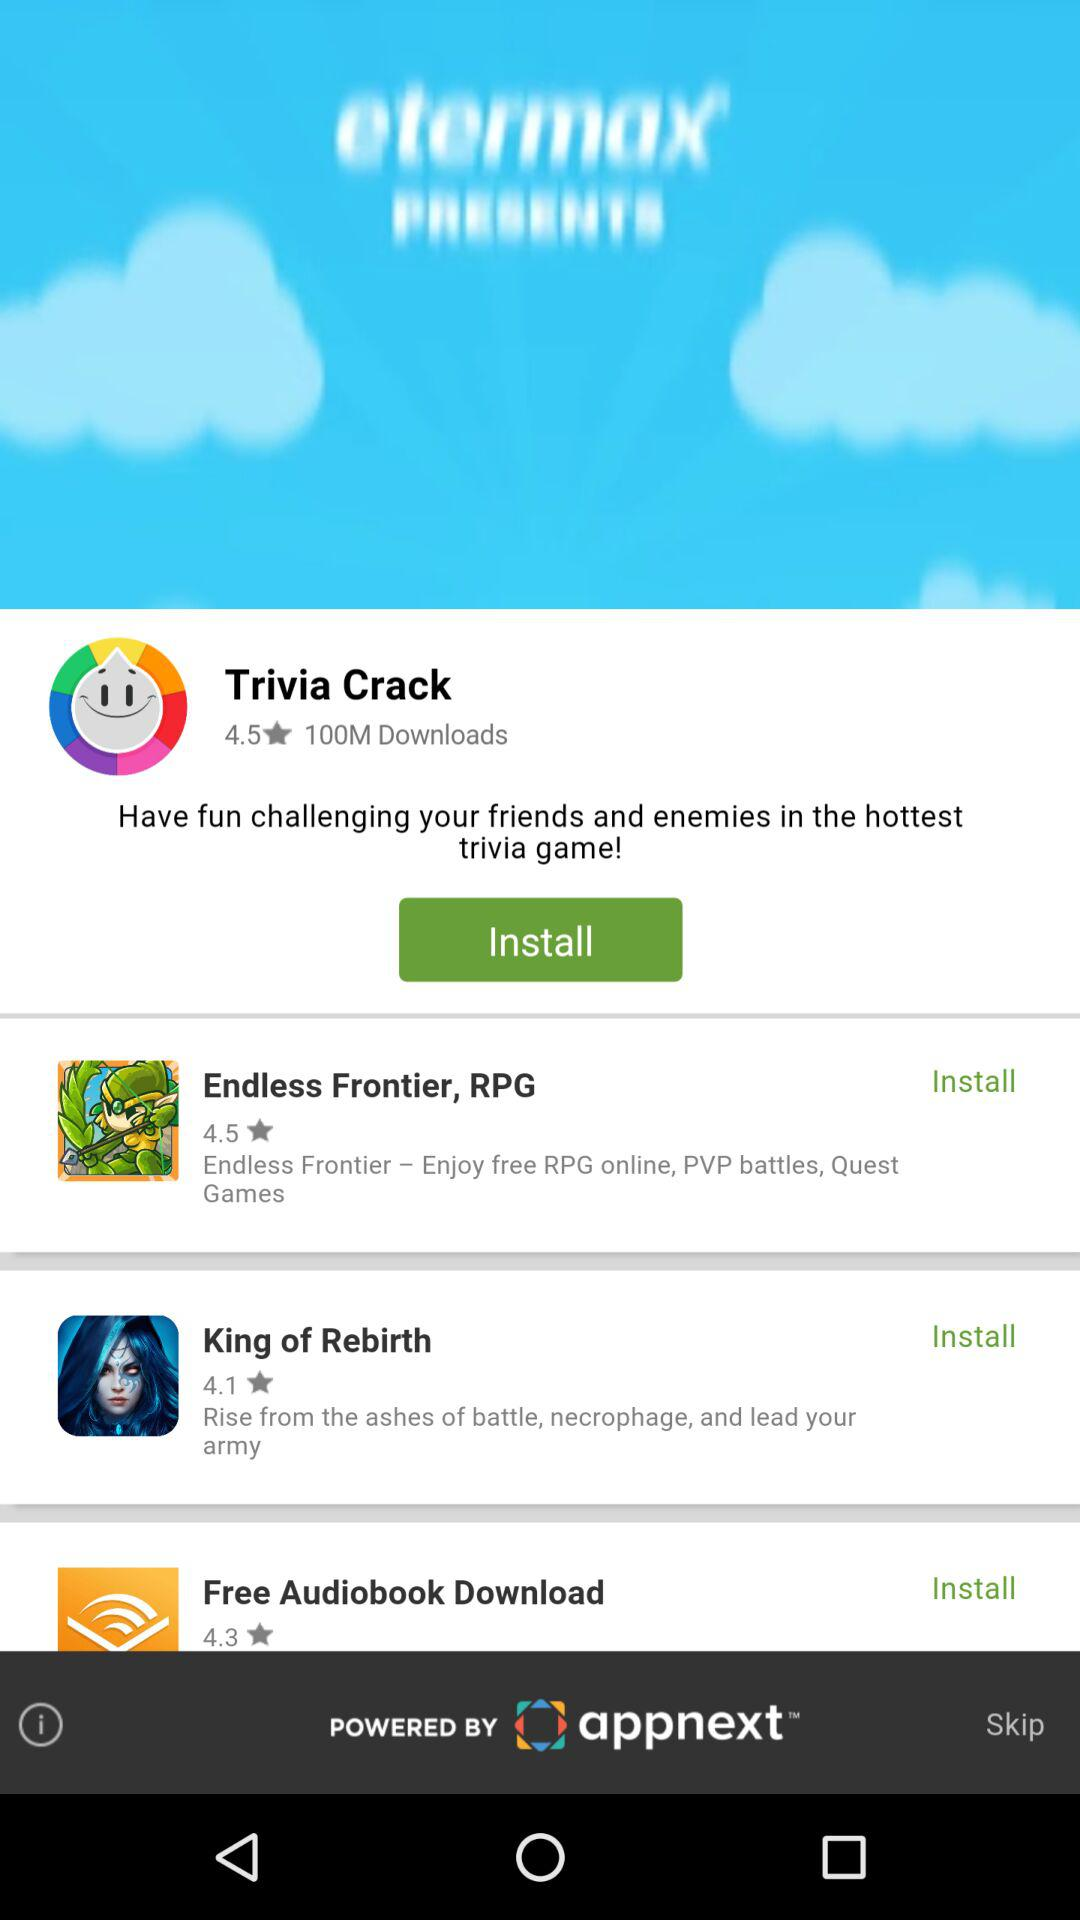What is the star rating of "King of Rebirth" application? The star rating of "King of Rebirth" application is 4.1. 